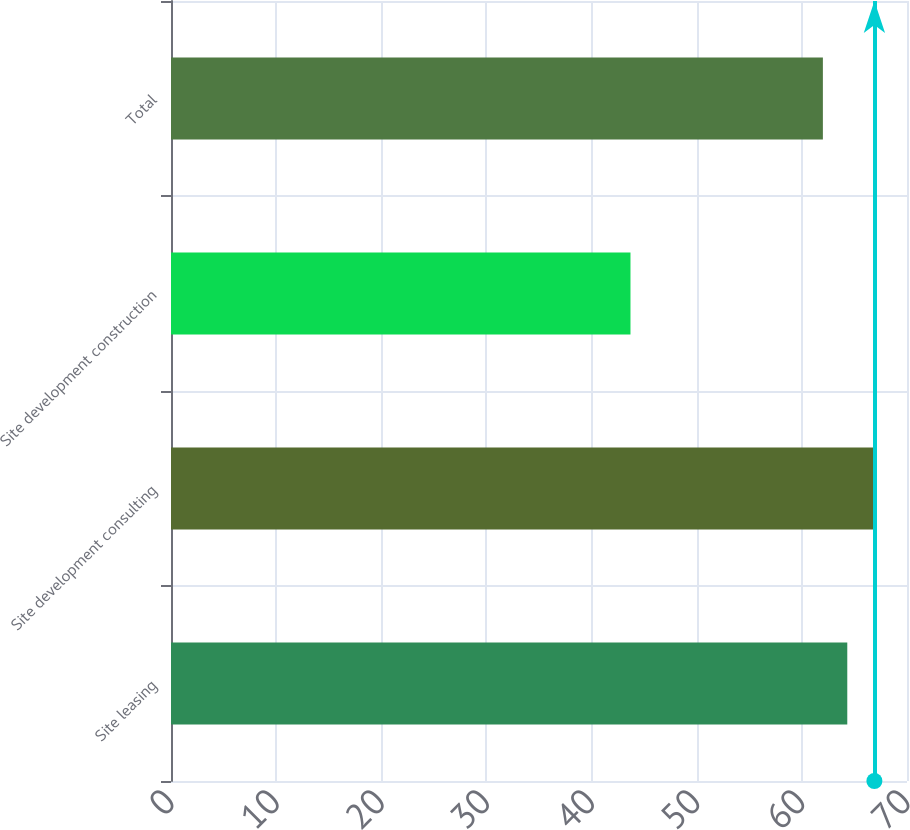Convert chart to OTSL. <chart><loc_0><loc_0><loc_500><loc_500><bar_chart><fcel>Site leasing<fcel>Site development consulting<fcel>Site development construction<fcel>Total<nl><fcel>64.32<fcel>66.9<fcel>43.7<fcel>62<nl></chart> 